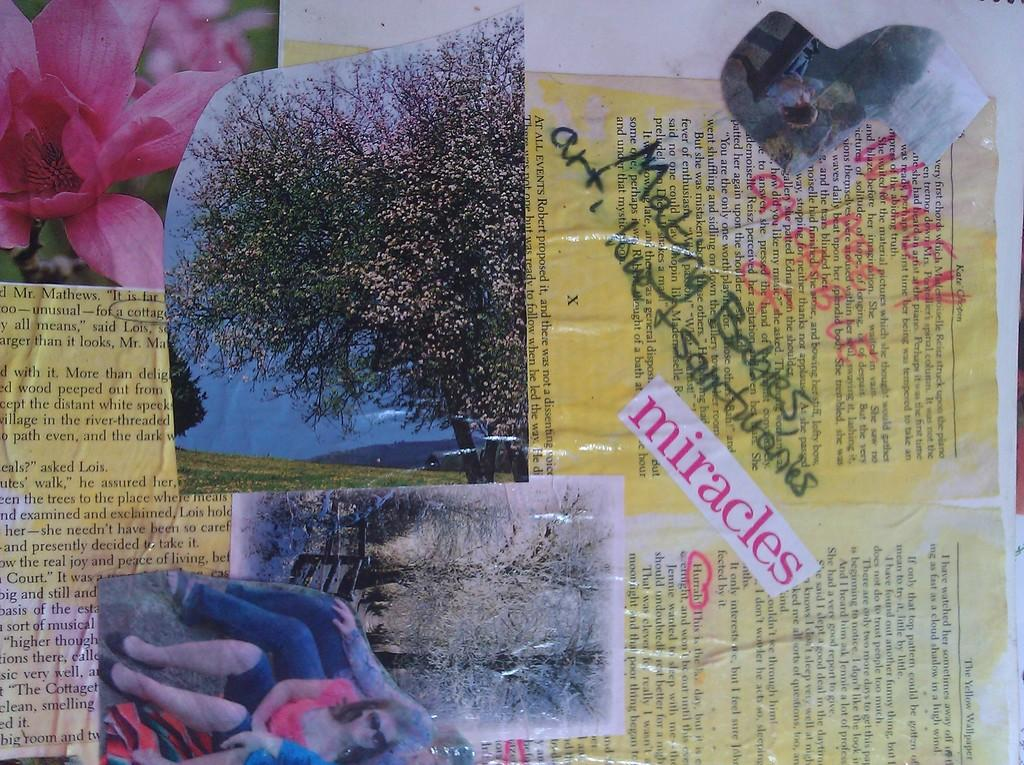What can be seen in the image related to visual memories? There are photographs in the image. What natural element is present in the image? There is a tree in the image. What type of plant life can be seen in the image? There are flowers in the image. Can you describe the people in the image? There is a group of persons in the image. What is the paper in the image used for? There is a paper in the image, and something is written on it. What type of riddle is written on the paper in the image? There is no riddle written on the paper in the image; it contains something written, but not a riddle. How does the health of the tree in the image compare to the flowers? The health of the tree and flowers cannot be determined from the image alone, as there is no information about their condition. 